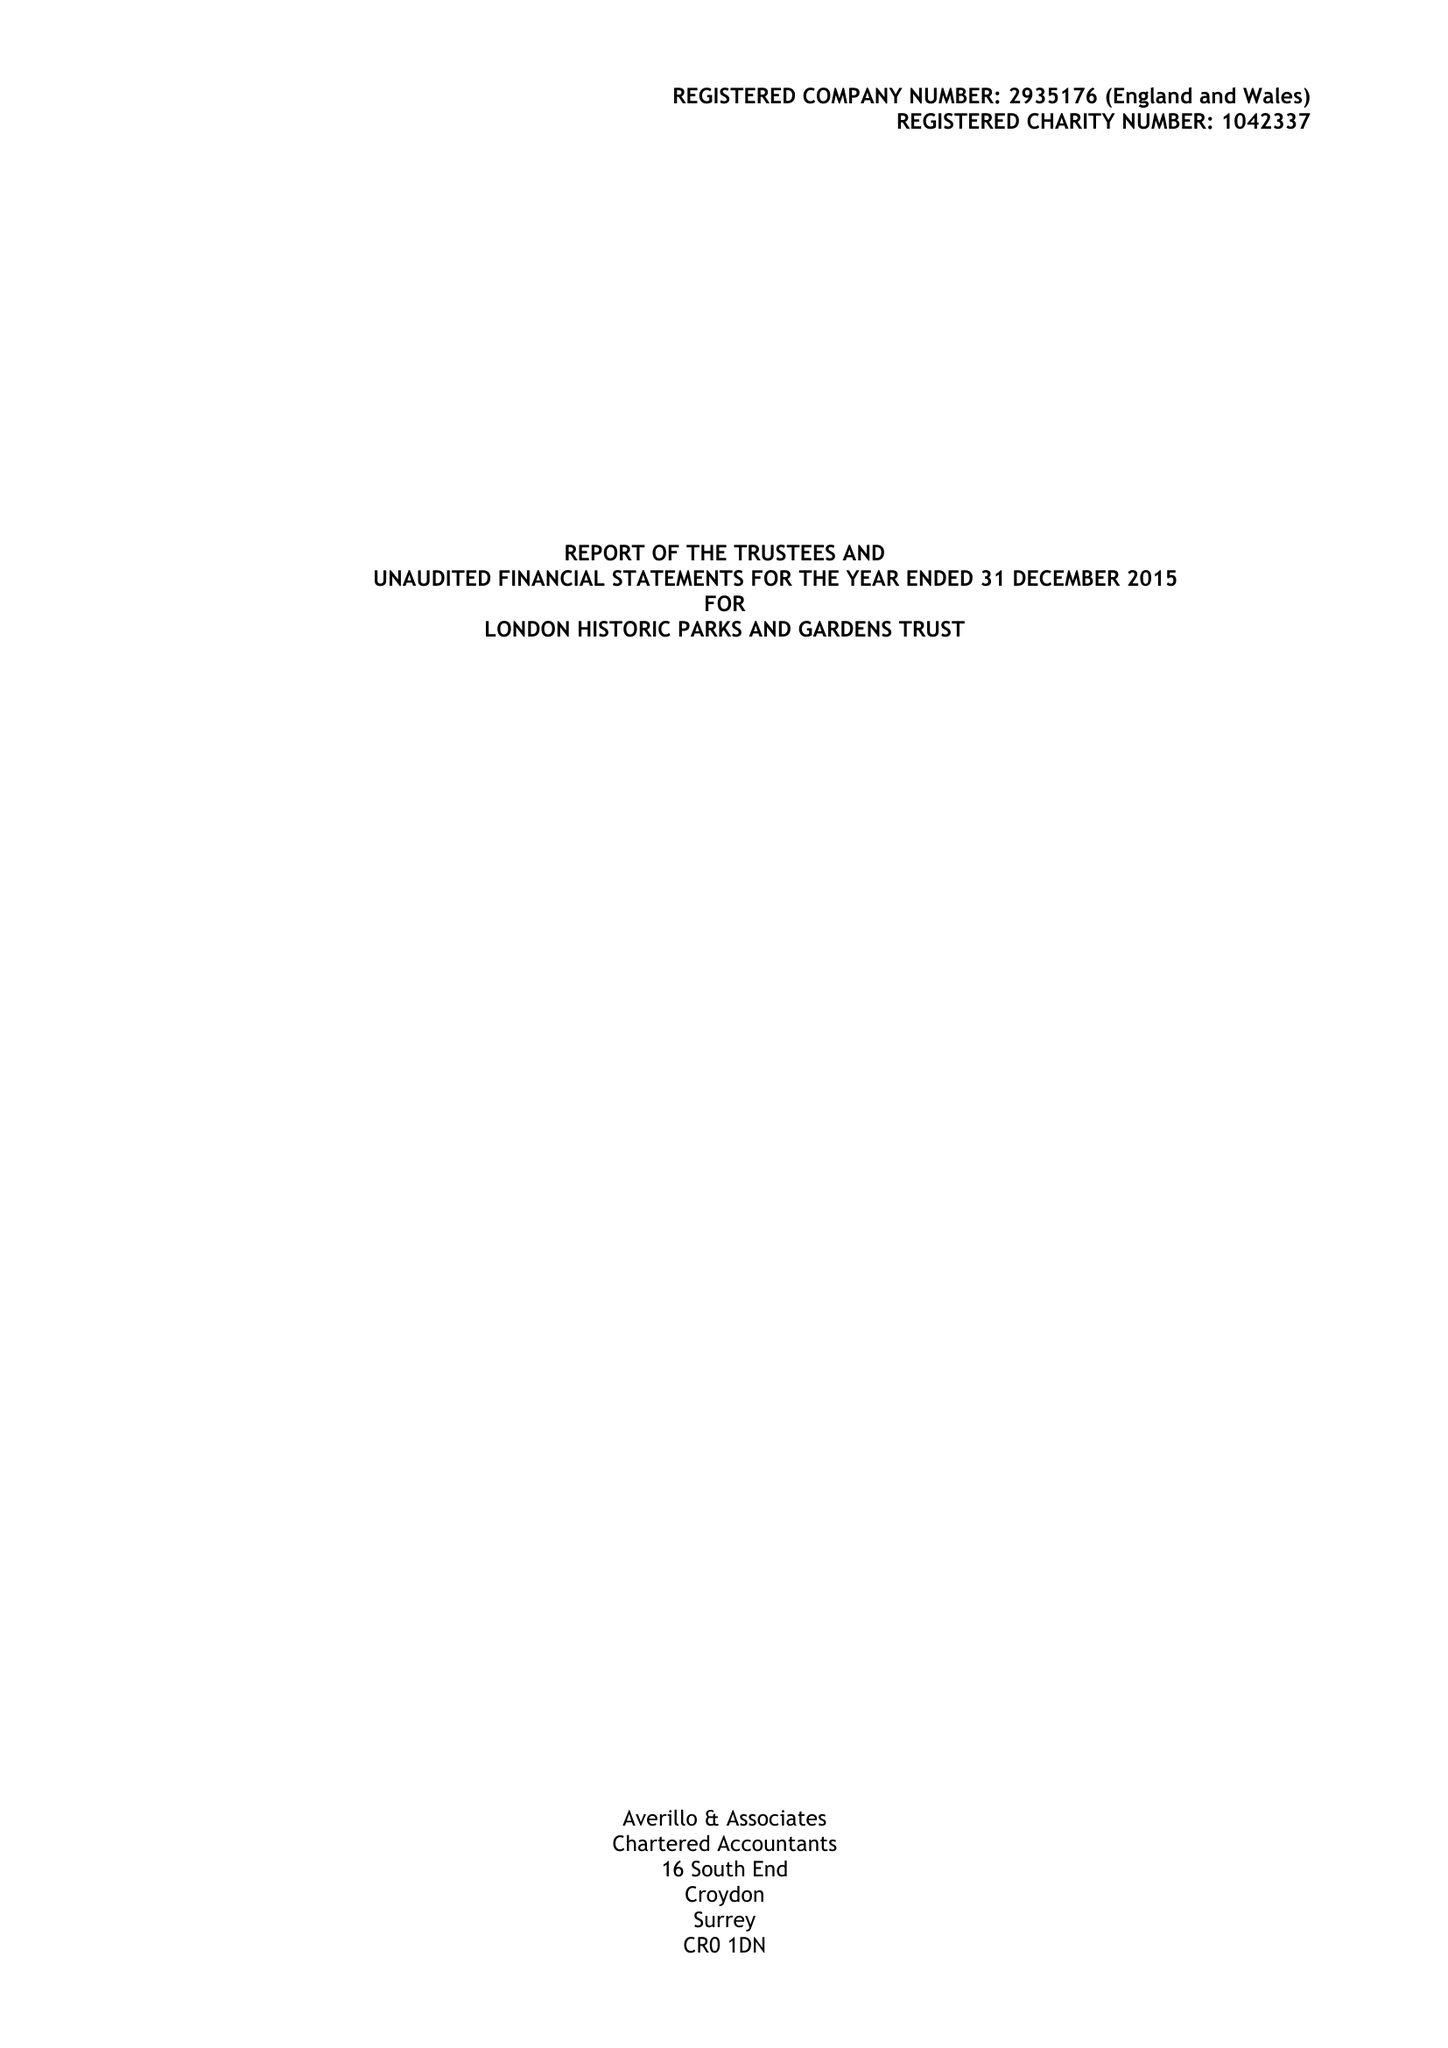What is the value for the address__post_town?
Answer the question using a single word or phrase. LONDON 